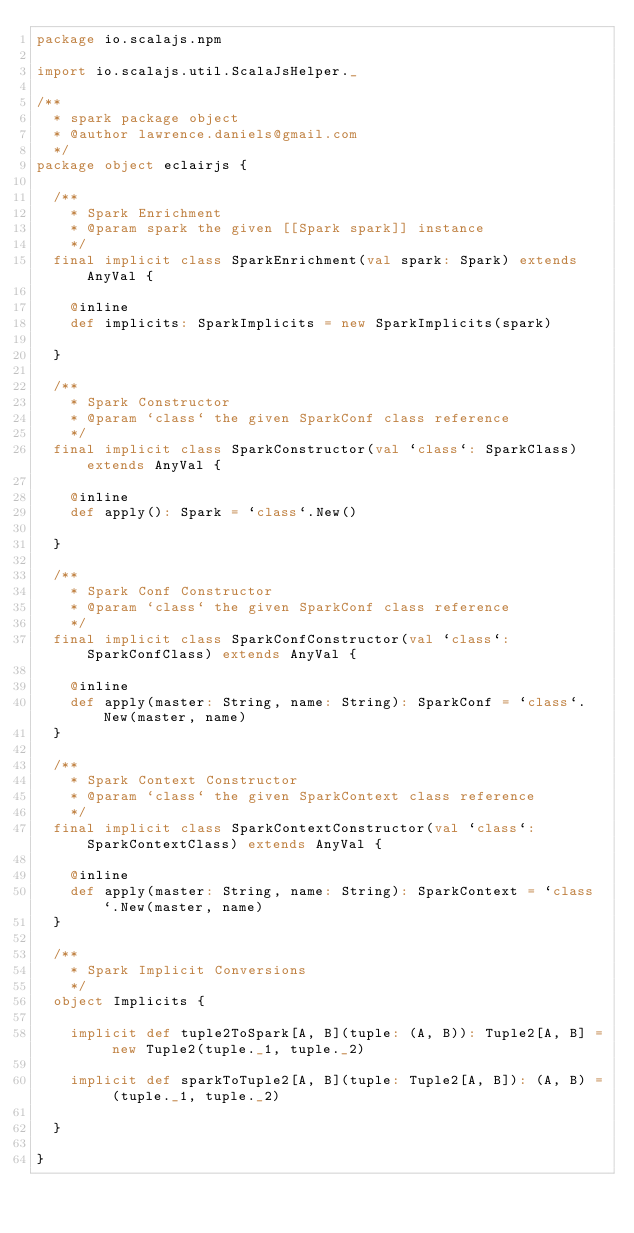Convert code to text. <code><loc_0><loc_0><loc_500><loc_500><_Scala_>package io.scalajs.npm

import io.scalajs.util.ScalaJsHelper._

/**
  * spark package object
  * @author lawrence.daniels@gmail.com
  */
package object eclairjs {

  /**
    * Spark Enrichment
    * @param spark the given [[Spark spark]] instance
    */
  final implicit class SparkEnrichment(val spark: Spark) extends AnyVal {

    @inline
    def implicits: SparkImplicits = new SparkImplicits(spark)

  }

  /**
    * Spark Constructor
    * @param `class` the given SparkConf class reference
    */
  final implicit class SparkConstructor(val `class`: SparkClass) extends AnyVal {

    @inline
    def apply(): Spark = `class`.New()

  }

  /**
    * Spark Conf Constructor
    * @param `class` the given SparkConf class reference
    */
  final implicit class SparkConfConstructor(val `class`: SparkConfClass) extends AnyVal {

    @inline
    def apply(master: String, name: String): SparkConf = `class`.New(master, name)
  }

  /**
    * Spark Context Constructor
    * @param `class` the given SparkContext class reference
    */
  final implicit class SparkContextConstructor(val `class`: SparkContextClass) extends AnyVal {

    @inline
    def apply(master: String, name: String): SparkContext = `class`.New(master, name)
  }

  /**
    * Spark Implicit Conversions
    */
  object Implicits {

    implicit def tuple2ToSpark[A, B](tuple: (A, B)): Tuple2[A, B] = new Tuple2(tuple._1, tuple._2)

    implicit def sparkToTuple2[A, B](tuple: Tuple2[A, B]): (A, B) = (tuple._1, tuple._2)

  }

}
</code> 